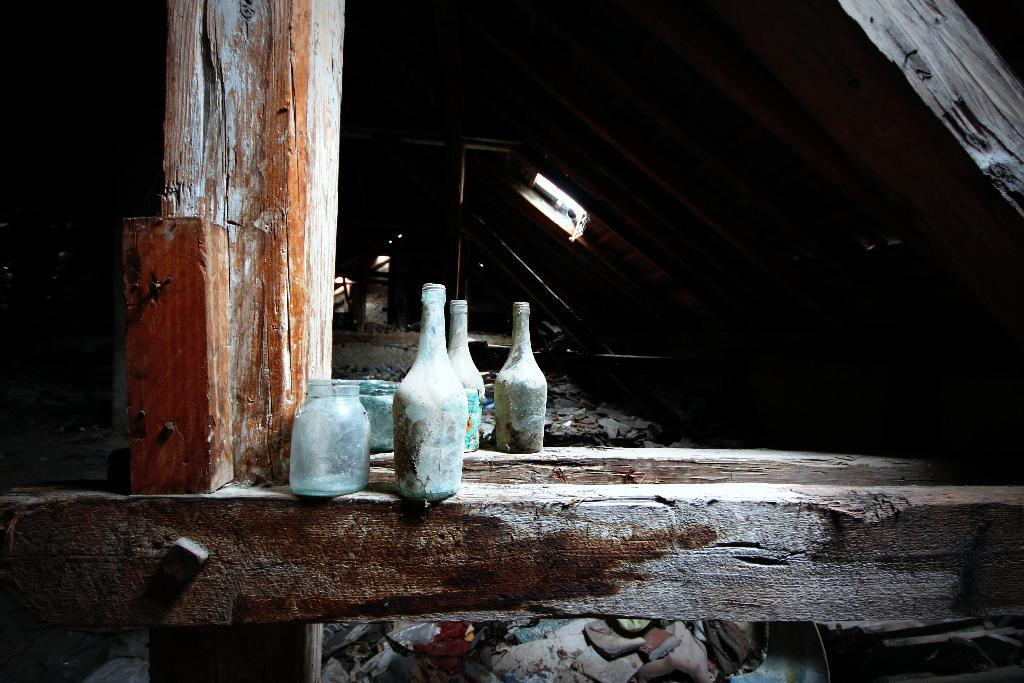How many containers are visible in the image? There are three bottles and two jars in the image, making a total of five containers. What is the surface on which the bottles and jars are placed? The bottles and jars are placed on a wooden log. What type of paper is being used to wrap the brick in the image? There is no paper or brick present in the image; it only features bottles and jars placed on a wooden log. 